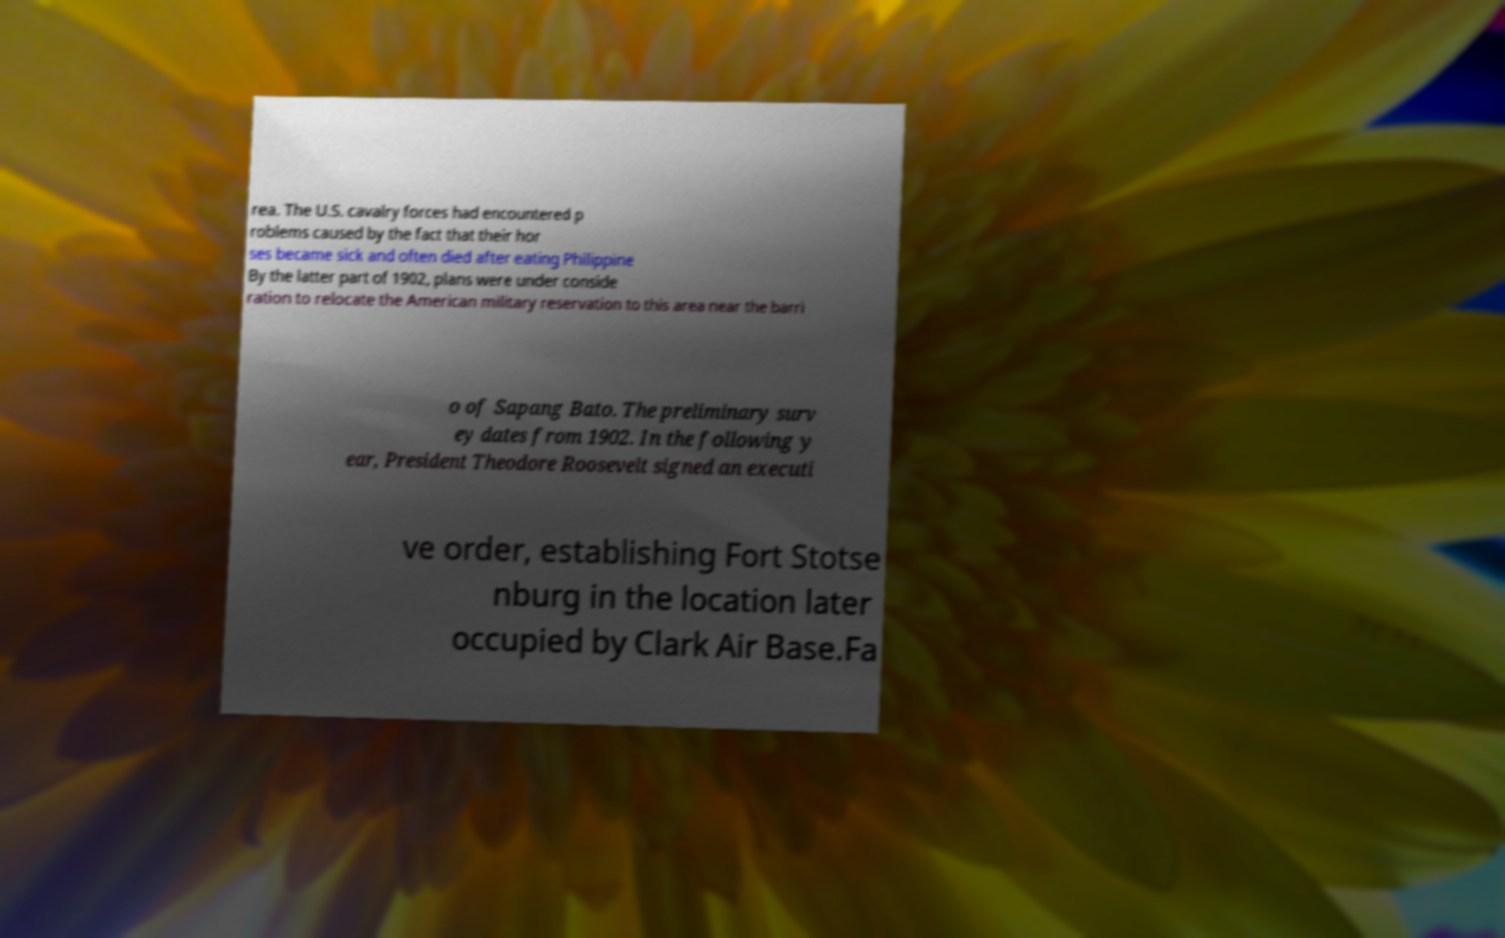I need the written content from this picture converted into text. Can you do that? rea. The U.S. cavalry forces had encountered p roblems caused by the fact that their hor ses became sick and often died after eating Philippine By the latter part of 1902, plans were under conside ration to relocate the American military reservation to this area near the barri o of Sapang Bato. The preliminary surv ey dates from 1902. In the following y ear, President Theodore Roosevelt signed an executi ve order, establishing Fort Stotse nburg in the location later occupied by Clark Air Base.Fa 